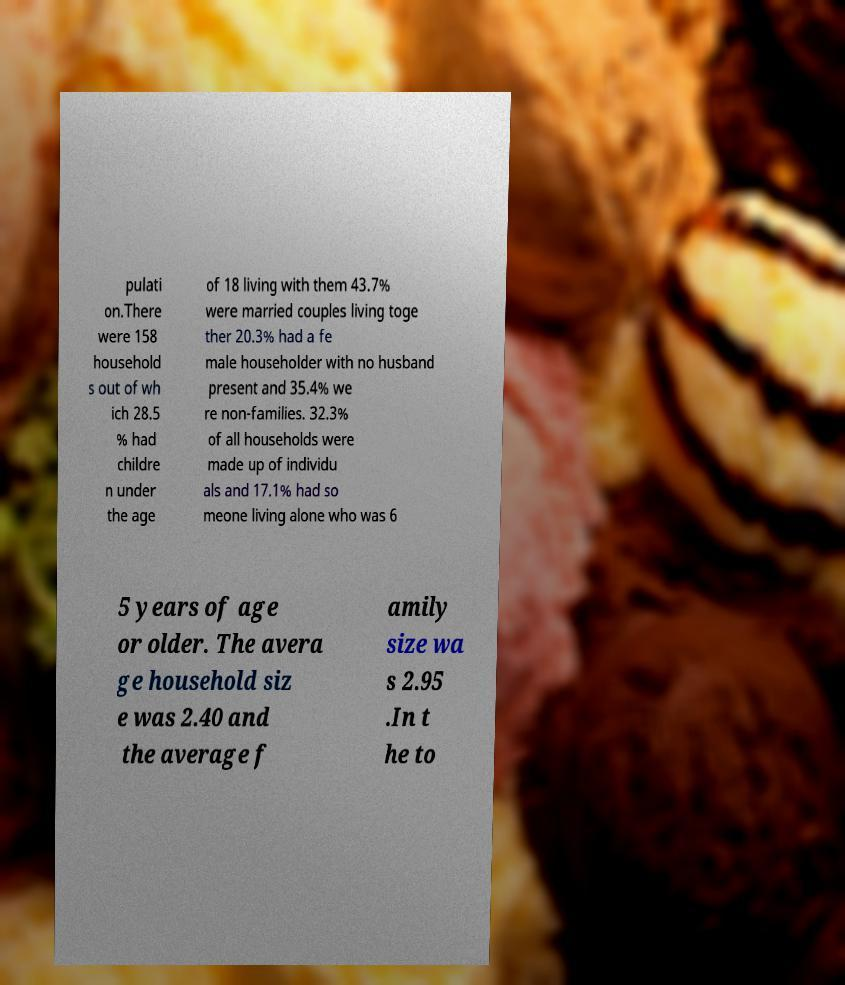For documentation purposes, I need the text within this image transcribed. Could you provide that? pulati on.There were 158 household s out of wh ich 28.5 % had childre n under the age of 18 living with them 43.7% were married couples living toge ther 20.3% had a fe male householder with no husband present and 35.4% we re non-families. 32.3% of all households were made up of individu als and 17.1% had so meone living alone who was 6 5 years of age or older. The avera ge household siz e was 2.40 and the average f amily size wa s 2.95 .In t he to 